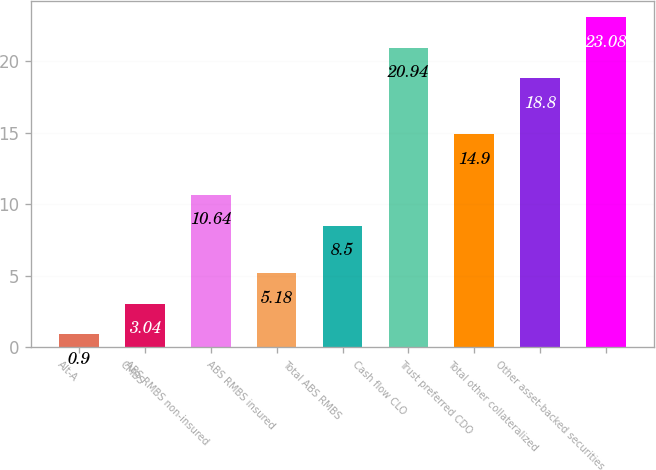Convert chart. <chart><loc_0><loc_0><loc_500><loc_500><bar_chart><fcel>Alt-A<fcel>CMBS<fcel>ABS RMBS non-insured<fcel>ABS RMBS insured<fcel>Total ABS RMBS<fcel>Cash flow CLO<fcel>Trust preferred CDO<fcel>Total other collateralized<fcel>Other asset-backed securities<nl><fcel>0.9<fcel>3.04<fcel>10.64<fcel>5.18<fcel>8.5<fcel>20.94<fcel>14.9<fcel>18.8<fcel>23.08<nl></chart> 